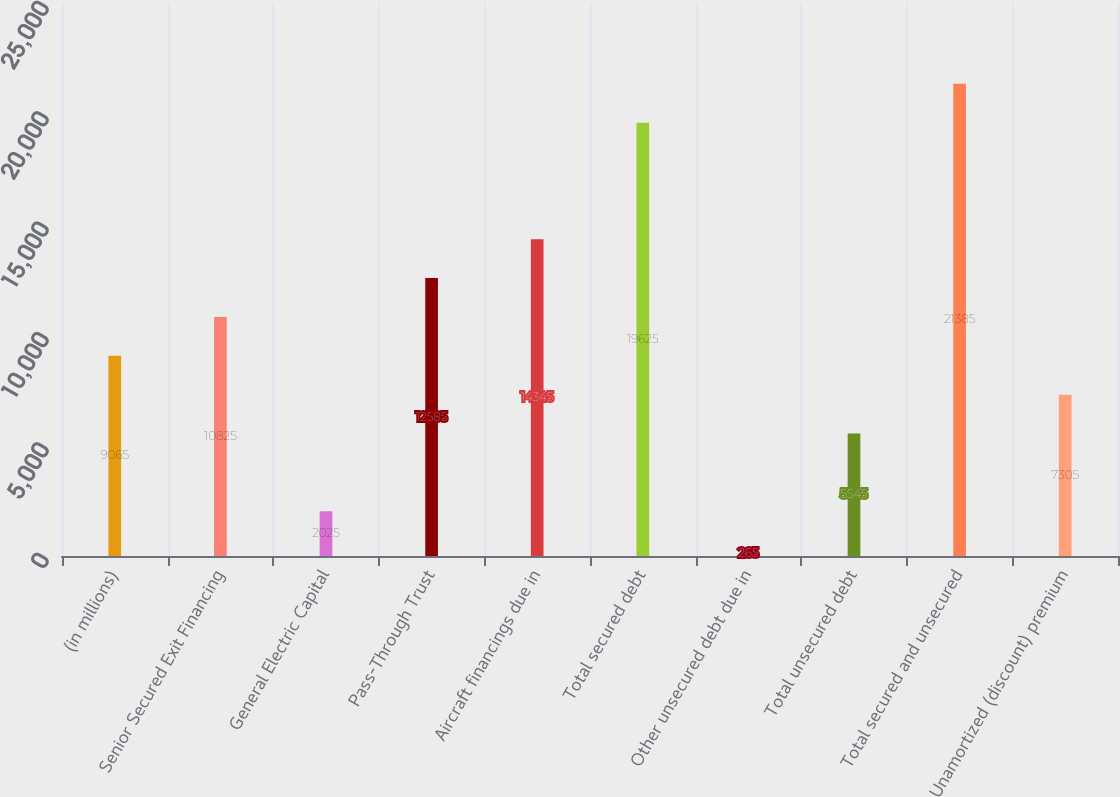Convert chart to OTSL. <chart><loc_0><loc_0><loc_500><loc_500><bar_chart><fcel>(in millions)<fcel>Senior Secured Exit Financing<fcel>General Electric Capital<fcel>Pass-Through Trust<fcel>Aircraft financings due in<fcel>Total secured debt<fcel>Other unsecured debt due in<fcel>Total unsecured debt<fcel>Total secured and unsecured<fcel>Unamortized (discount) premium<nl><fcel>9065<fcel>10825<fcel>2025<fcel>12585<fcel>14345<fcel>19625<fcel>265<fcel>5545<fcel>21385<fcel>7305<nl></chart> 